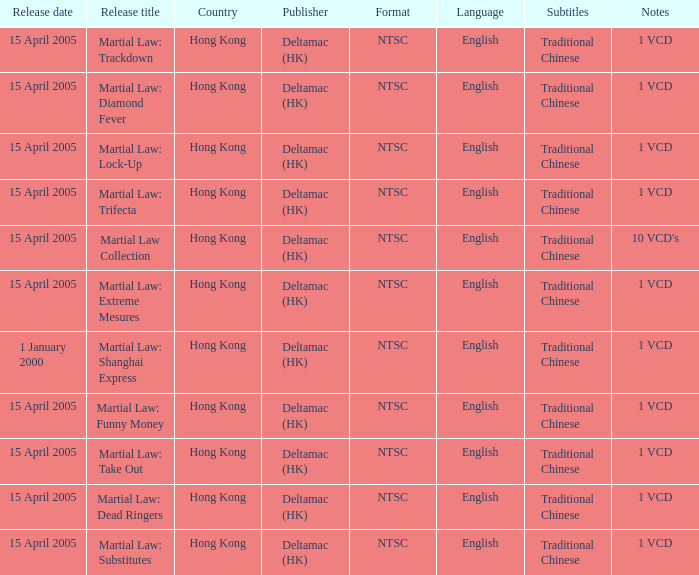What is the country that saw the release of a vcd named "martial law: substitutes"? Hong Kong. 